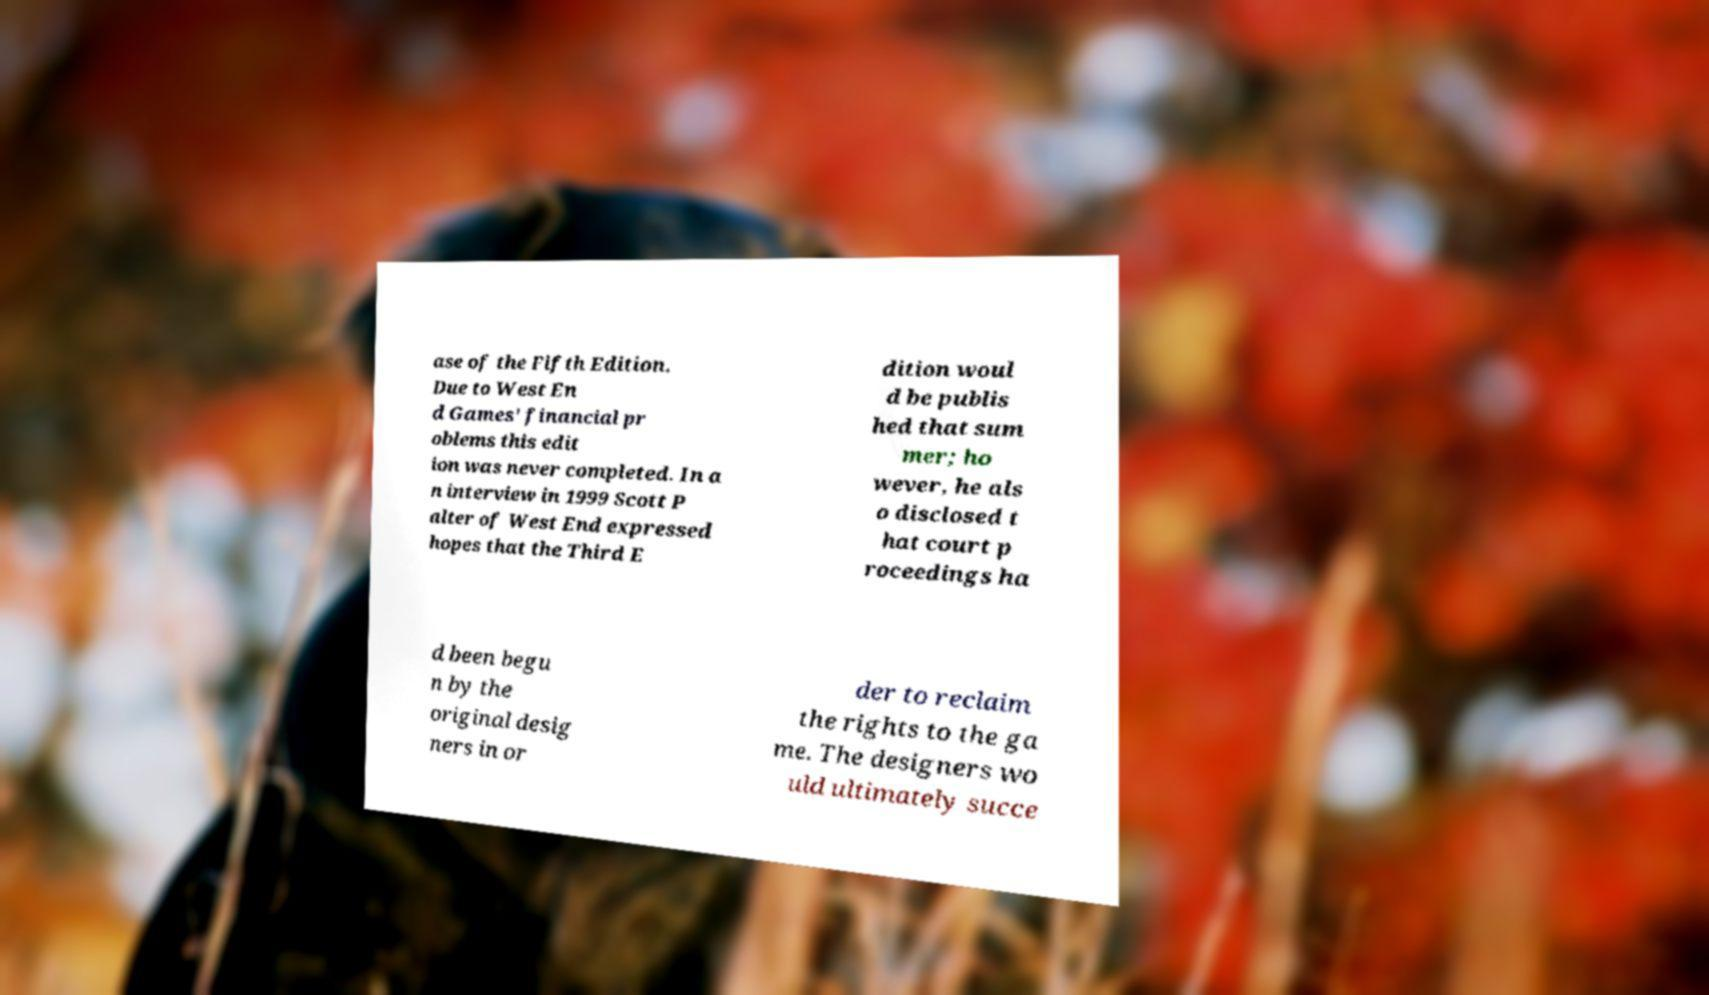I need the written content from this picture converted into text. Can you do that? ase of the Fifth Edition. Due to West En d Games' financial pr oblems this edit ion was never completed. In a n interview in 1999 Scott P alter of West End expressed hopes that the Third E dition woul d be publis hed that sum mer; ho wever, he als o disclosed t hat court p roceedings ha d been begu n by the original desig ners in or der to reclaim the rights to the ga me. The designers wo uld ultimately succe 